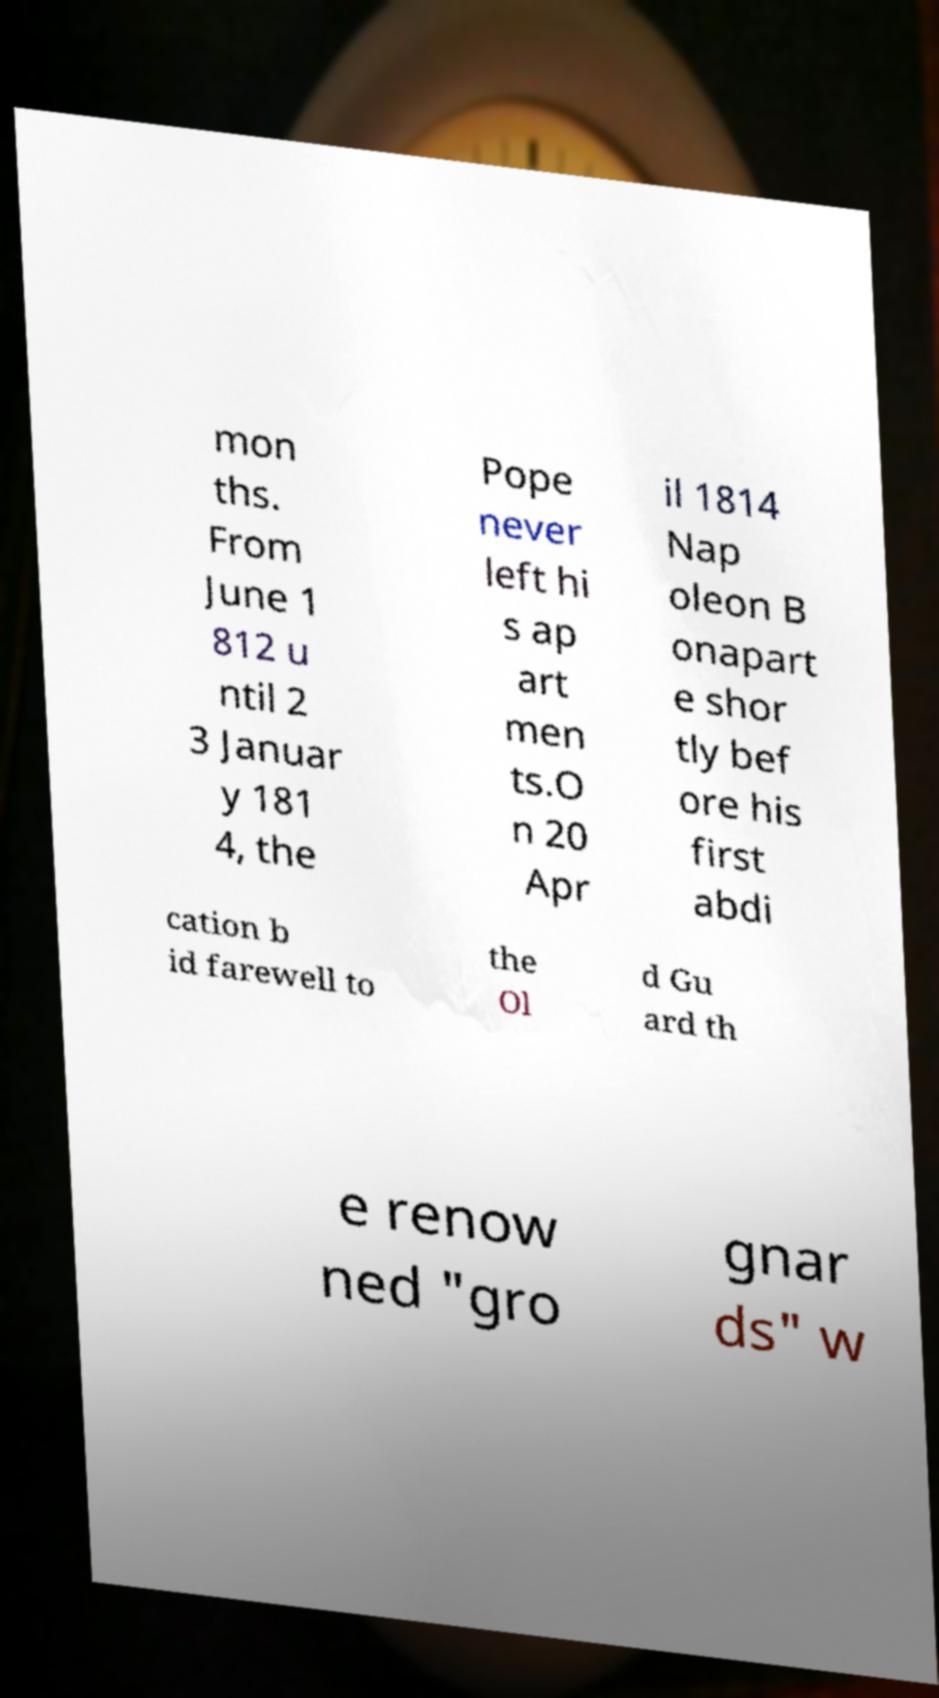Could you assist in decoding the text presented in this image and type it out clearly? mon ths. From June 1 812 u ntil 2 3 Januar y 181 4, the Pope never left hi s ap art men ts.O n 20 Apr il 1814 Nap oleon B onapart e shor tly bef ore his first abdi cation b id farewell to the Ol d Gu ard th e renow ned "gro gnar ds" w 